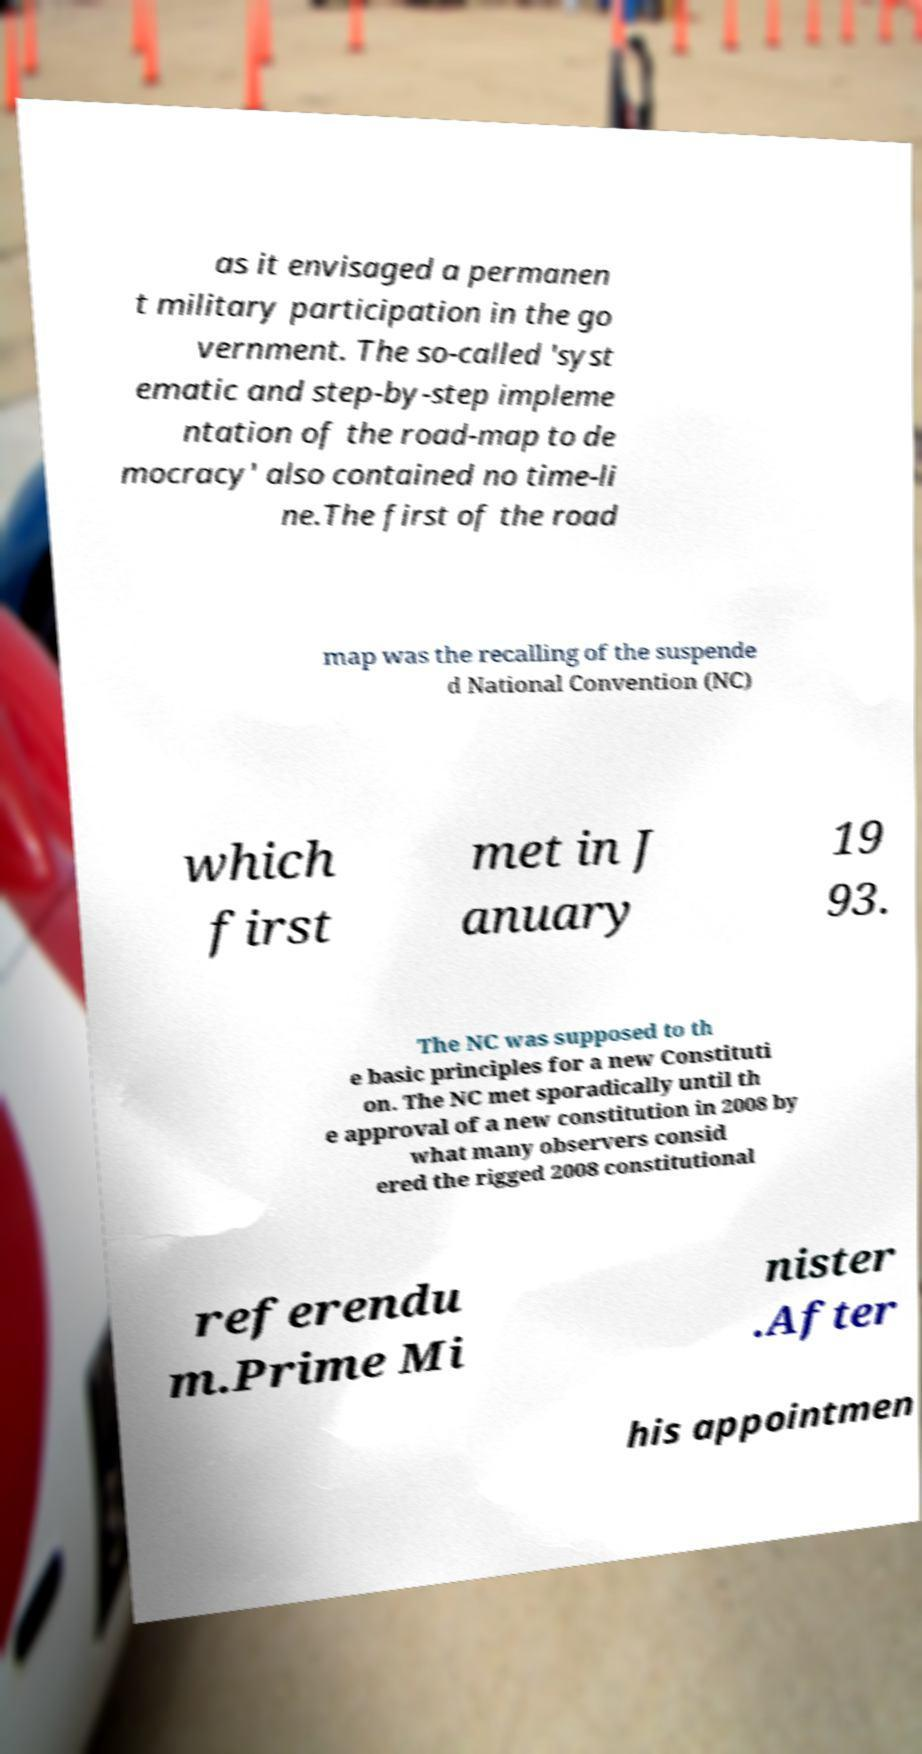Please read and relay the text visible in this image. What does it say? as it envisaged a permanen t military participation in the go vernment. The so-called 'syst ematic and step-by-step impleme ntation of the road-map to de mocracy' also contained no time-li ne.The first of the road map was the recalling of the suspende d National Convention (NC) which first met in J anuary 19 93. The NC was supposed to th e basic principles for a new Constituti on. The NC met sporadically until th e approval of a new constitution in 2008 by what many observers consid ered the rigged 2008 constitutional referendu m.Prime Mi nister .After his appointmen 